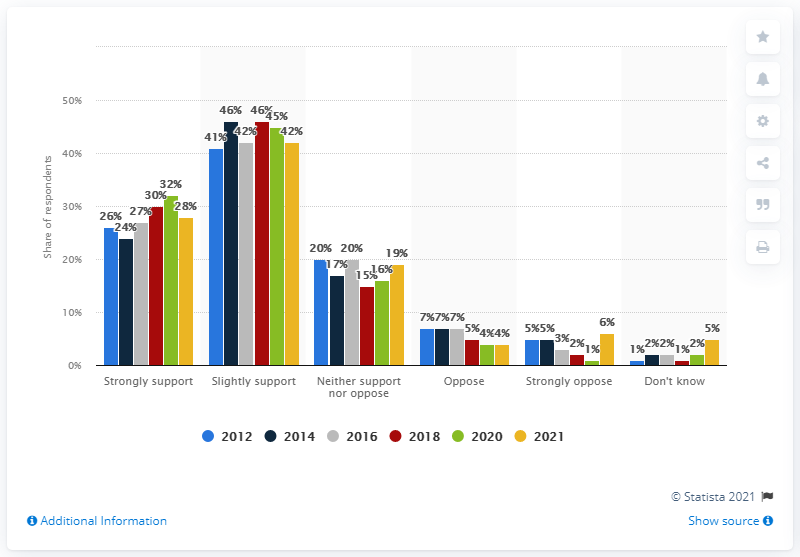Outline some significant characteristics in this image. In 2021, support for on-shore wind renewable energy in the UK reached 70 percent. 